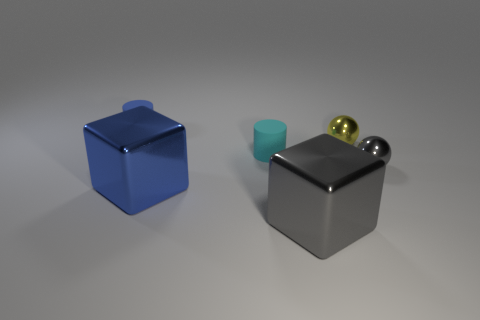The tiny object that is both in front of the blue cylinder and on the left side of the yellow object has what shape?
Make the answer very short. Cylinder. What number of tiny green objects have the same shape as the large blue thing?
Make the answer very short. 0. What is the size of the yellow sphere that is the same material as the blue cube?
Offer a very short reply. Small. Is the number of cylinders greater than the number of cyan matte cylinders?
Provide a short and direct response. Yes. What is the color of the cylinder that is right of the small blue thing?
Your answer should be compact. Cyan. How big is the thing that is both left of the small cyan matte object and in front of the cyan rubber cylinder?
Make the answer very short. Large. What number of gray metal blocks have the same size as the blue cube?
Keep it short and to the point. 1. There is a blue thing that is the same shape as the tiny cyan rubber object; what is it made of?
Make the answer very short. Rubber. Do the tiny yellow metal thing and the cyan matte thing have the same shape?
Your answer should be very brief. No. What number of tiny metallic spheres are behind the small gray object?
Your answer should be very brief. 1. 